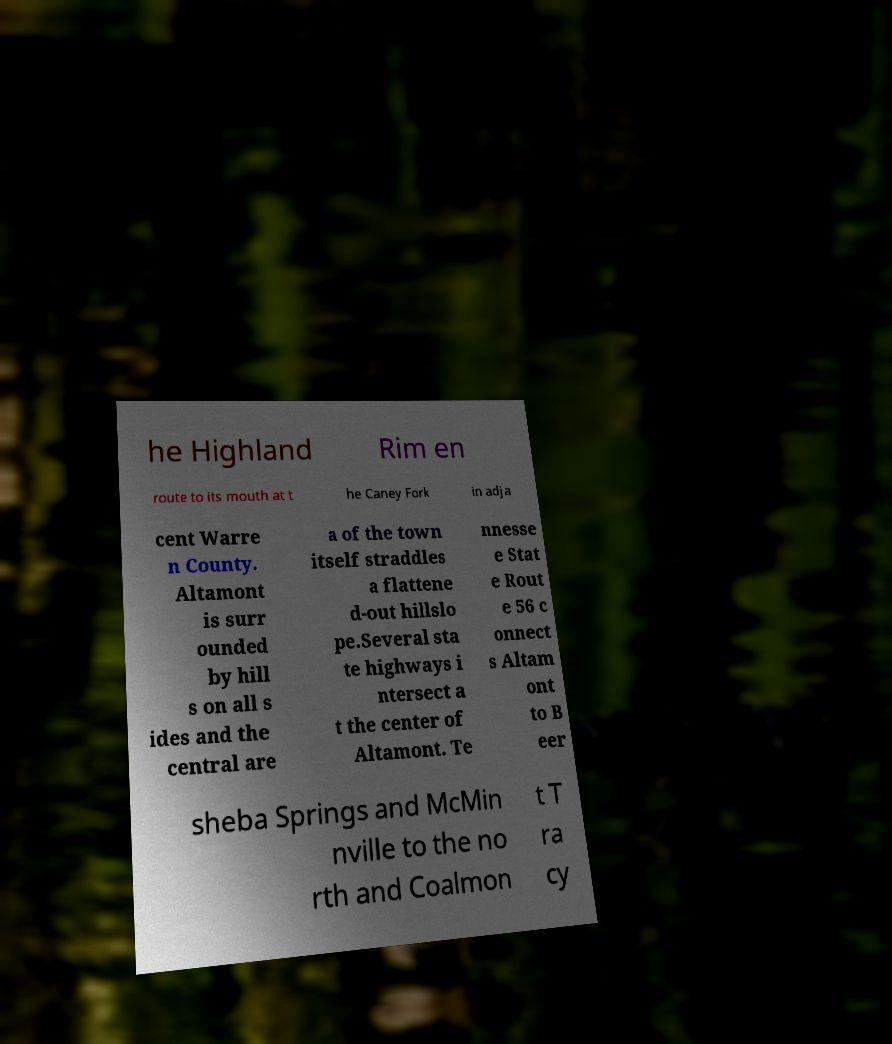I need the written content from this picture converted into text. Can you do that? he Highland Rim en route to its mouth at t he Caney Fork in adja cent Warre n County. Altamont is surr ounded by hill s on all s ides and the central are a of the town itself straddles a flattene d-out hillslo pe.Several sta te highways i ntersect a t the center of Altamont. Te nnesse e Stat e Rout e 56 c onnect s Altam ont to B eer sheba Springs and McMin nville to the no rth and Coalmon t T ra cy 